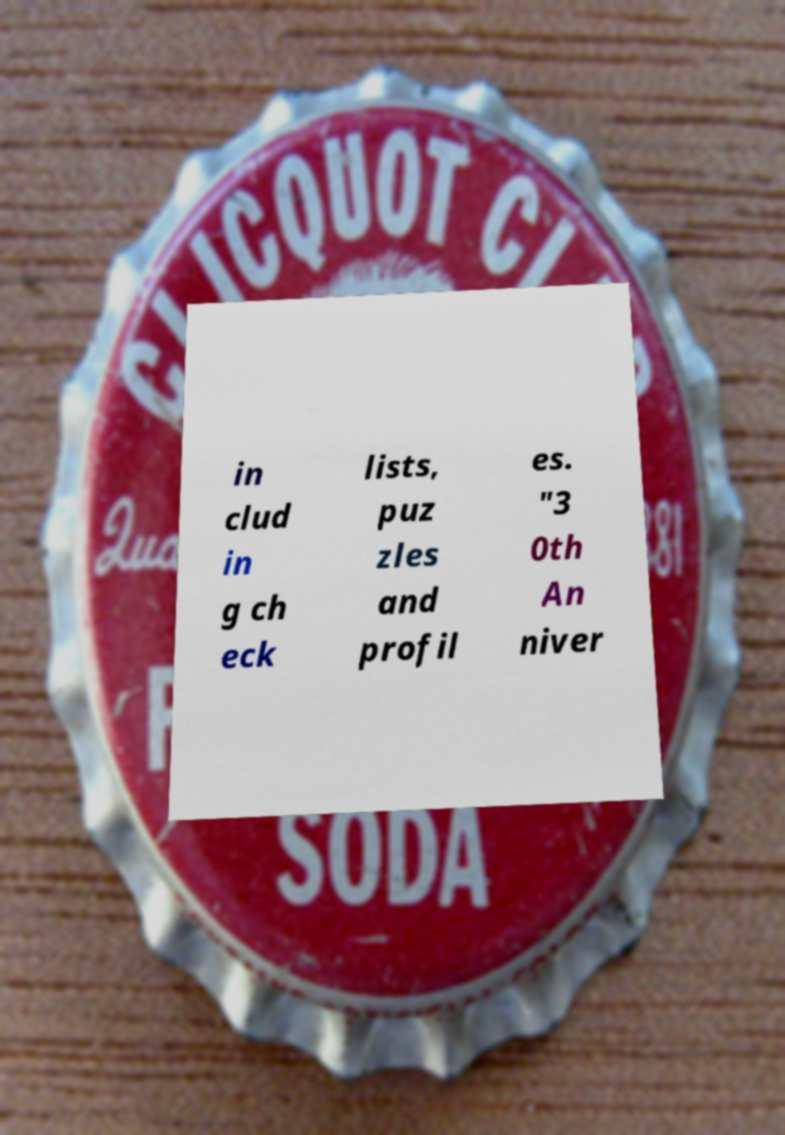What messages or text are displayed in this image? I need them in a readable, typed format. in clud in g ch eck lists, puz zles and profil es. "3 0th An niver 